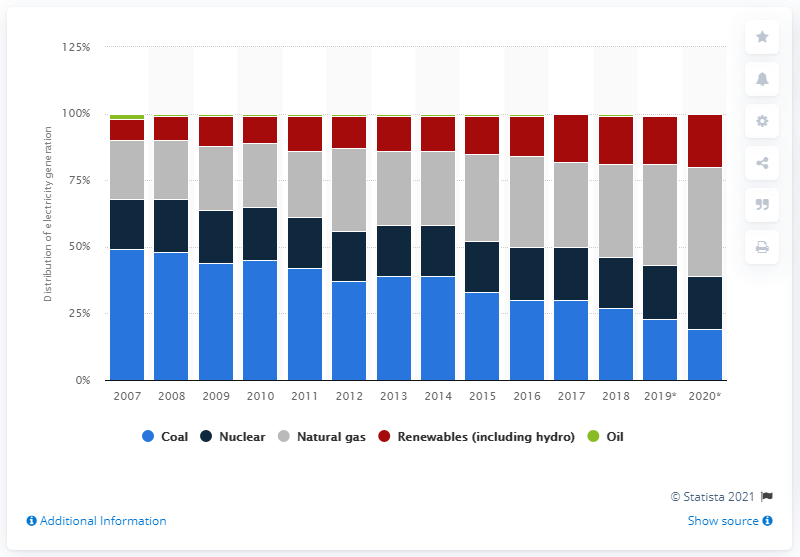Indicate a few pertinent items in this graphic. In 2015, coal and natural gas together accounted for approximately 33% of the total electricity generation worldwide. 